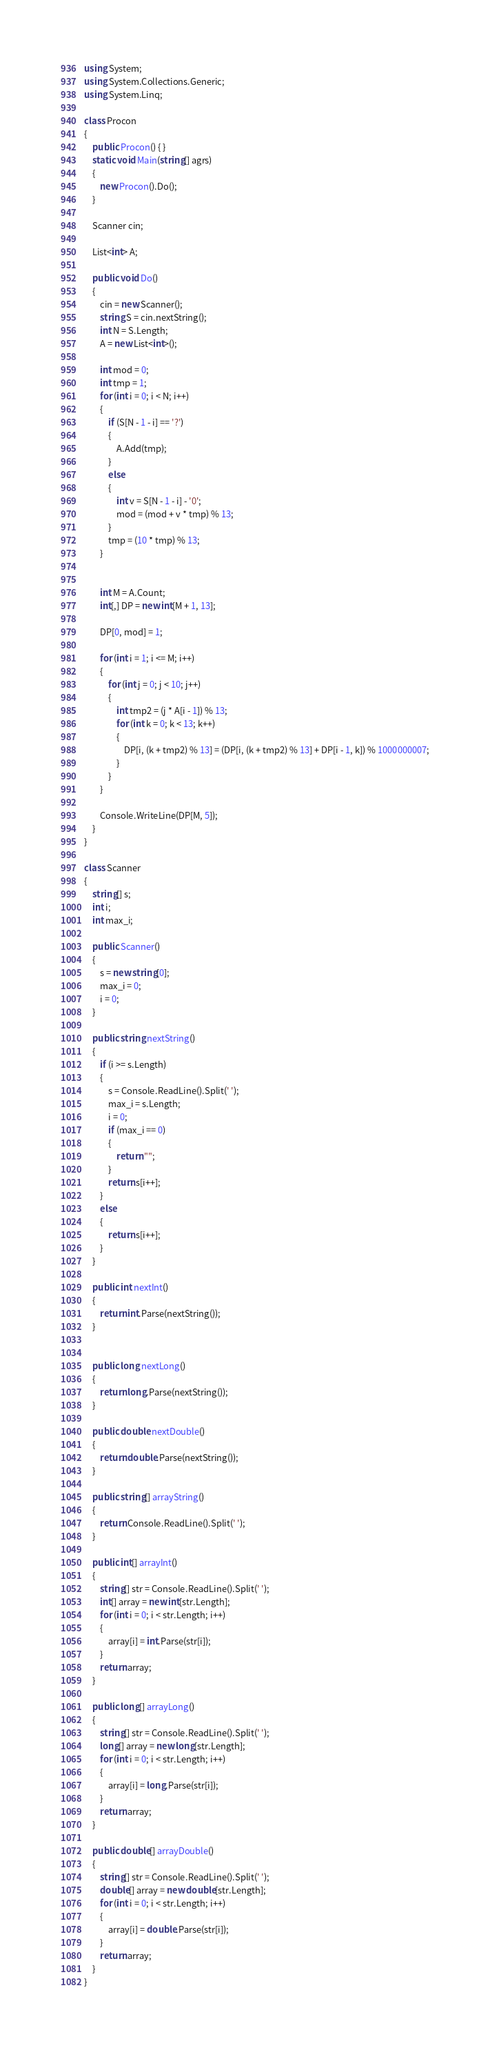Convert code to text. <code><loc_0><loc_0><loc_500><loc_500><_C#_>using System;
using System.Collections.Generic;
using System.Linq;

class Procon
{
    public Procon() { }
    static void Main(string[] agrs)
    {
        new Procon().Do();
    }

    Scanner cin;

    List<int> A;

    public void Do()
    {
        cin = new Scanner();
        string S = cin.nextString();
        int N = S.Length;
        A = new List<int>();

        int mod = 0;
        int tmp = 1;
        for (int i = 0; i < N; i++)
        {
            if (S[N - 1 - i] == '?')
            {
                A.Add(tmp);
            }
            else
            {
                int v = S[N - 1 - i] - '0';
                mod = (mod + v * tmp) % 13;
            }
            tmp = (10 * tmp) % 13;
        }


        int M = A.Count;
        int[,] DP = new int[M + 1, 13];

        DP[0, mod] = 1;

        for (int i = 1; i <= M; i++)
        {
            for (int j = 0; j < 10; j++)
            {
                int tmp2 = (j * A[i - 1]) % 13;
                for (int k = 0; k < 13; k++)
                {
                    DP[i, (k + tmp2) % 13] = (DP[i, (k + tmp2) % 13] + DP[i - 1, k]) % 1000000007;
                }
            }
        }

        Console.WriteLine(DP[M, 5]);
    }
}

class Scanner
{
    string[] s;
    int i;
    int max_i;

    public Scanner()
    {
        s = new string[0];
        max_i = 0;
        i = 0;
    }

    public string nextString()
    {
        if (i >= s.Length)
        {
            s = Console.ReadLine().Split(' ');
            max_i = s.Length;
            i = 0;
            if (max_i == 0)
            {
                return "";
            }
            return s[i++];
        }
        else
        {
            return s[i++];
        }
    }

    public int nextInt()
    {
        return int.Parse(nextString());
    }


    public long nextLong()
    {
        return long.Parse(nextString());
    }

    public double nextDouble()
    {
        return double.Parse(nextString());
    }

    public string[] arrayString()
    {
        return Console.ReadLine().Split(' ');
    }

    public int[] arrayInt()
    {
        string[] str = Console.ReadLine().Split(' ');
        int[] array = new int[str.Length];
        for (int i = 0; i < str.Length; i++)
        {
            array[i] = int.Parse(str[i]);
        }
        return array;
    }

    public long[] arrayLong()
    {
        string[] str = Console.ReadLine().Split(' ');
        long[] array = new long[str.Length];
        for (int i = 0; i < str.Length; i++)
        {
            array[i] = long.Parse(str[i]);
        }
        return array;
    }

    public double[] arrayDouble()
    {
        string[] str = Console.ReadLine().Split(' ');
        double[] array = new double[str.Length];
        for (int i = 0; i < str.Length; i++)
        {
            array[i] = double.Parse(str[i]);
        }
        return array;
    }
}
</code> 